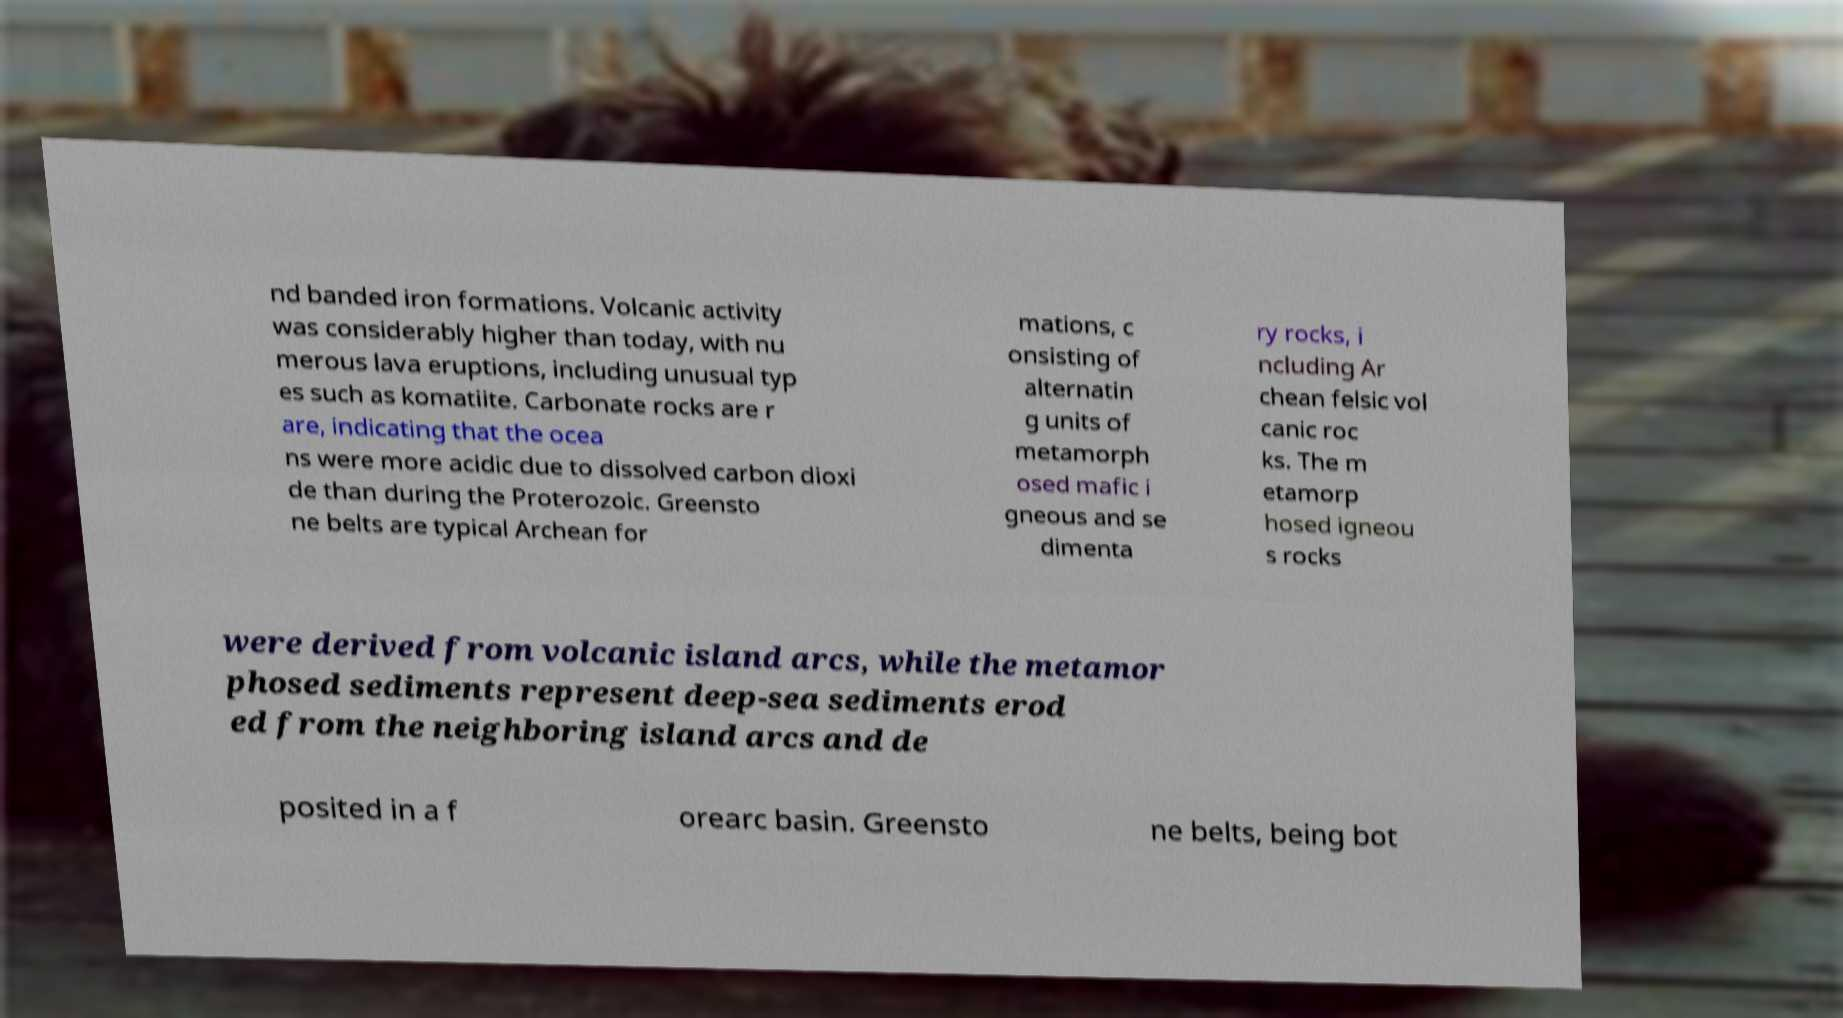There's text embedded in this image that I need extracted. Can you transcribe it verbatim? nd banded iron formations. Volcanic activity was considerably higher than today, with nu merous lava eruptions, including unusual typ es such as komatiite. Carbonate rocks are r are, indicating that the ocea ns were more acidic due to dissolved carbon dioxi de than during the Proterozoic. Greensto ne belts are typical Archean for mations, c onsisting of alternatin g units of metamorph osed mafic i gneous and se dimenta ry rocks, i ncluding Ar chean felsic vol canic roc ks. The m etamorp hosed igneou s rocks were derived from volcanic island arcs, while the metamor phosed sediments represent deep-sea sediments erod ed from the neighboring island arcs and de posited in a f orearc basin. Greensto ne belts, being bot 